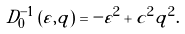Convert formula to latex. <formula><loc_0><loc_0><loc_500><loc_500>D _ { 0 } ^ { - 1 } \left ( \varepsilon , q \right ) = - \varepsilon ^ { 2 } + c ^ { 2 } q ^ { 2 } .</formula> 